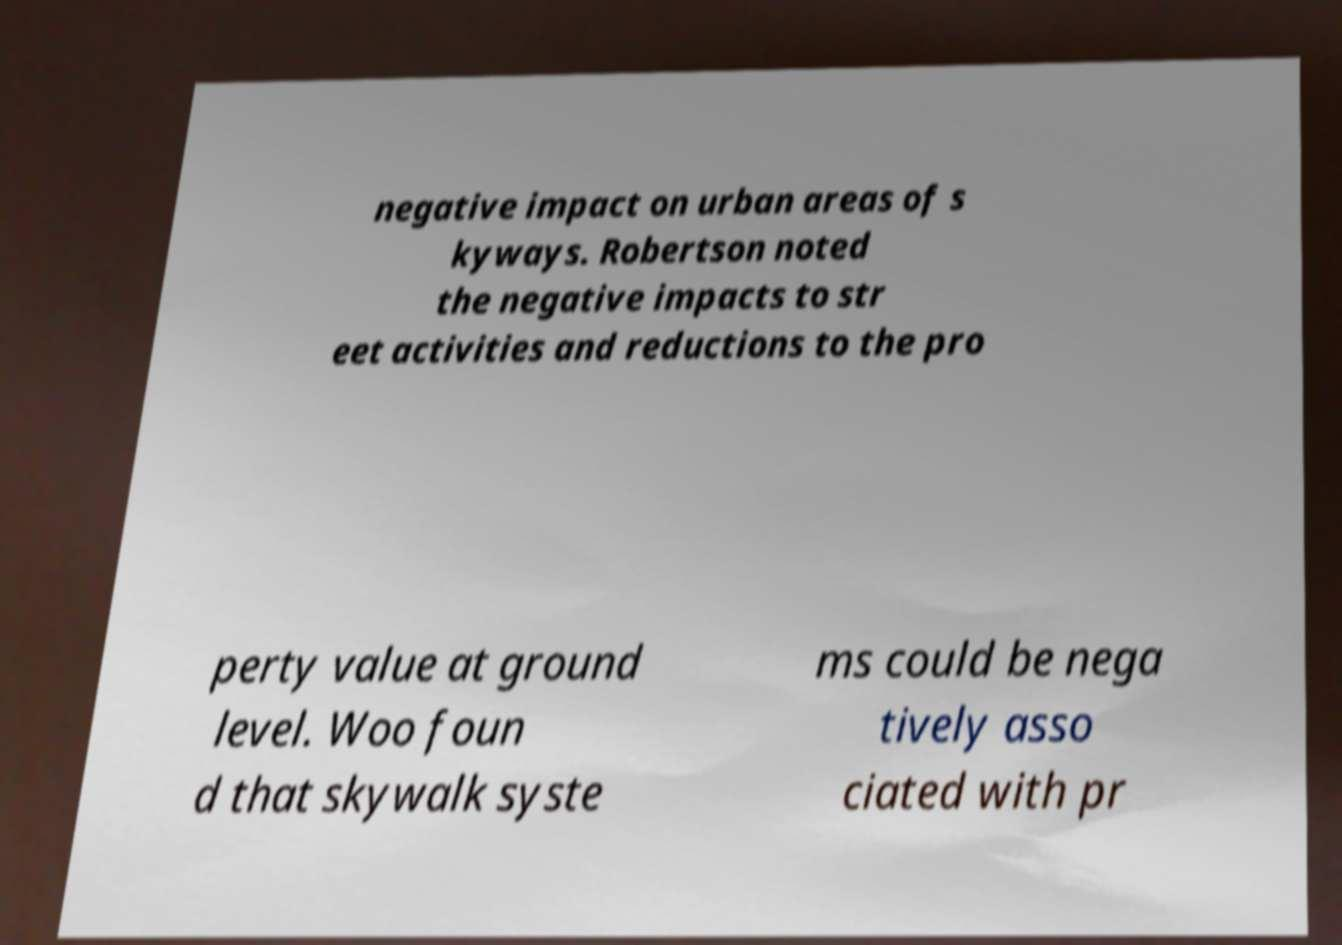Could you extract and type out the text from this image? negative impact on urban areas of s kyways. Robertson noted the negative impacts to str eet activities and reductions to the pro perty value at ground level. Woo foun d that skywalk syste ms could be nega tively asso ciated with pr 